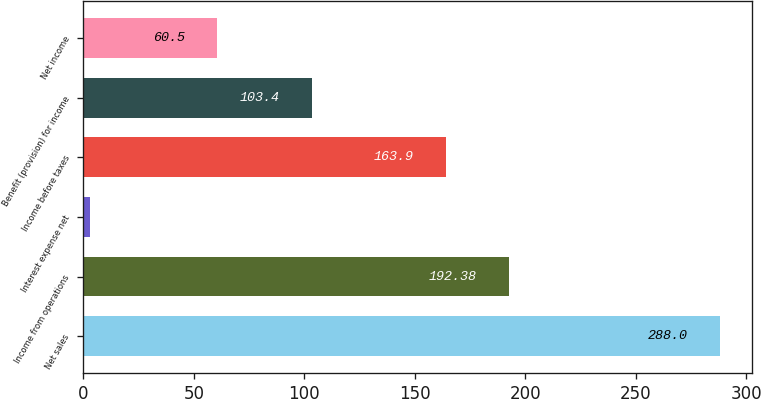<chart> <loc_0><loc_0><loc_500><loc_500><bar_chart><fcel>Net sales<fcel>Income from operations<fcel>Interest expense net<fcel>Income before taxes<fcel>Benefit (provision) for income<fcel>Net income<nl><fcel>288<fcel>192.38<fcel>3.2<fcel>163.9<fcel>103.4<fcel>60.5<nl></chart> 